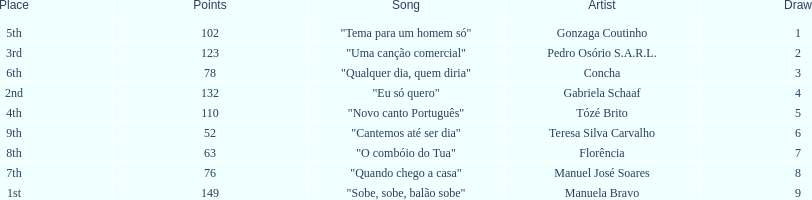Which artist came in last place? Teresa Silva Carvalho. 